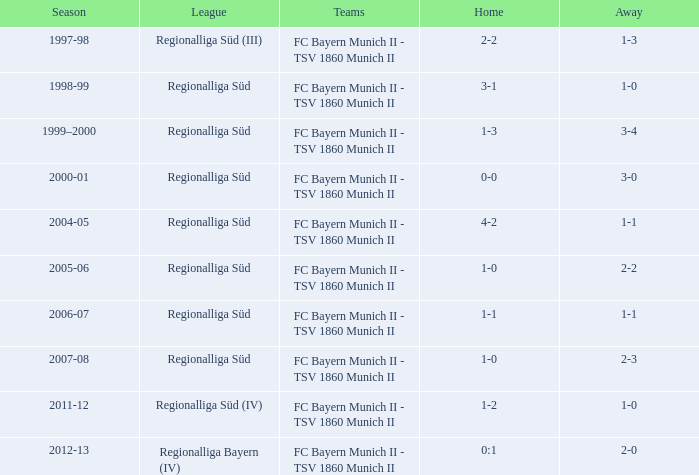Which teams were in the 2006-07 season? FC Bayern Munich II - TSV 1860 Munich II. Would you mind parsing the complete table? {'header': ['Season', 'League', 'Teams', 'Home', 'Away'], 'rows': [['1997-98', 'Regionalliga Süd (III)', 'FC Bayern Munich II - TSV 1860 Munich II', '2-2', '1-3'], ['1998-99', 'Regionalliga Süd', 'FC Bayern Munich II - TSV 1860 Munich II', '3-1', '1-0'], ['1999–2000', 'Regionalliga Süd', 'FC Bayern Munich II - TSV 1860 Munich II', '1-3', '3-4'], ['2000-01', 'Regionalliga Süd', 'FC Bayern Munich II - TSV 1860 Munich II', '0-0', '3-0'], ['2004-05', 'Regionalliga Süd', 'FC Bayern Munich II - TSV 1860 Munich II', '4-2', '1-1'], ['2005-06', 'Regionalliga Süd', 'FC Bayern Munich II - TSV 1860 Munich II', '1-0', '2-2'], ['2006-07', 'Regionalliga Süd', 'FC Bayern Munich II - TSV 1860 Munich II', '1-1', '1-1'], ['2007-08', 'Regionalliga Süd', 'FC Bayern Munich II - TSV 1860 Munich II', '1-0', '2-3'], ['2011-12', 'Regionalliga Süd (IV)', 'FC Bayern Munich II - TSV 1860 Munich II', '1-2', '1-0'], ['2012-13', 'Regionalliga Bayern (IV)', 'FC Bayern Munich II - TSV 1860 Munich II', '0:1', '2-0']]} 